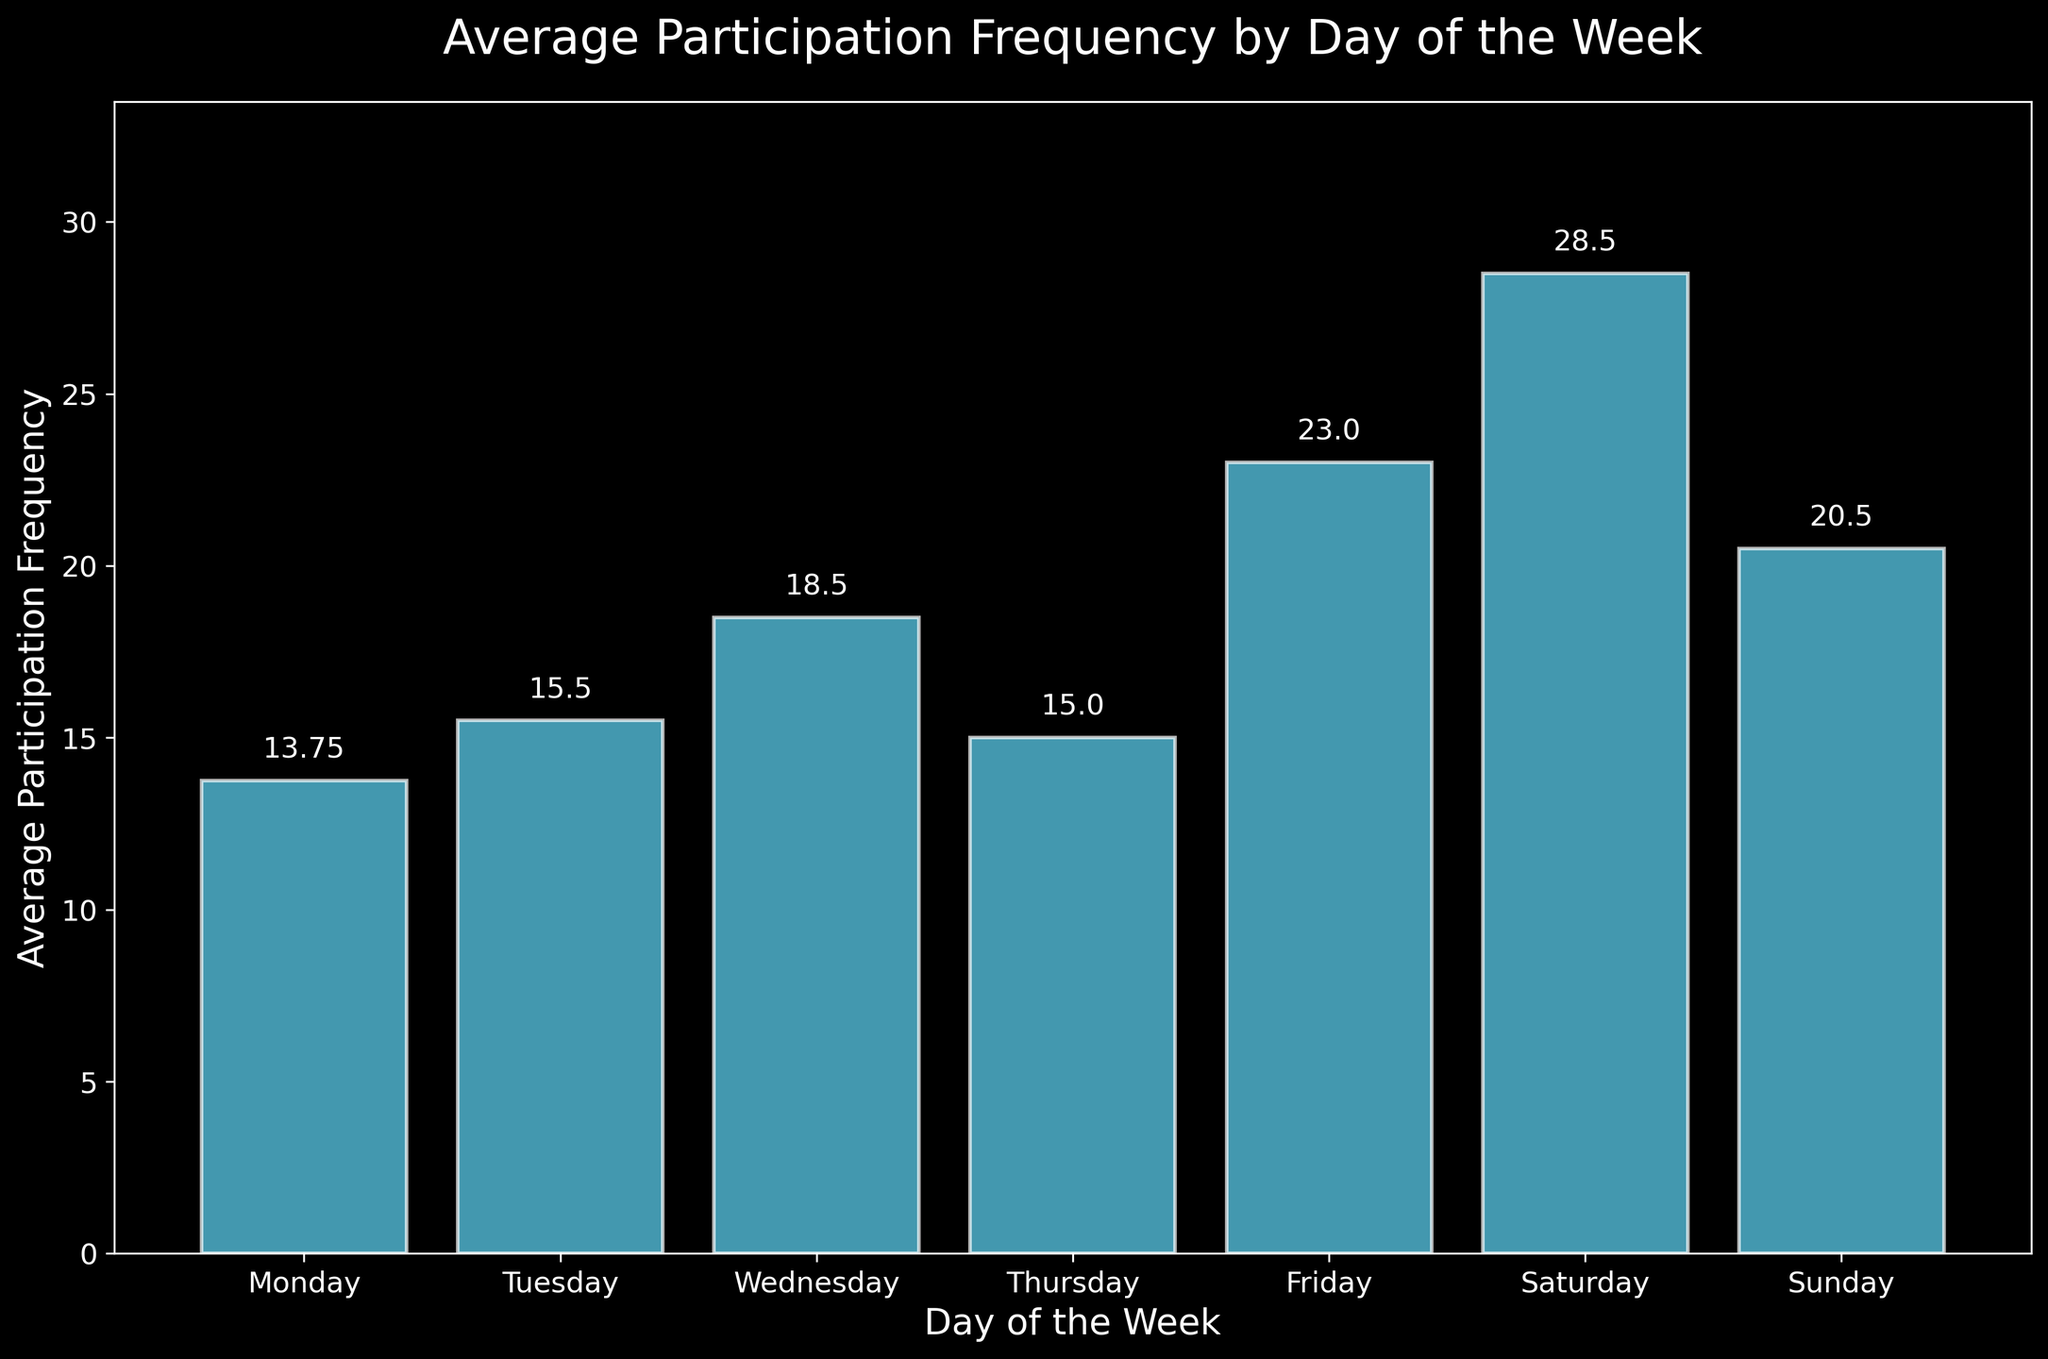Which day has the highest average participation frequency? From the figure, the bar representing Saturday is the tallest, indicating that it has the highest average participation frequency.
Answer: Saturday What is the difference in average participation between the highest and lowest days? The highest average participation is on Saturday (28.8) and the lowest is on Monday (13.75). The difference is calculated as 28.8 - 13.75 = 15.05.
Answer: 15.05 How does the average participation frequency on Friday compare to Sunday? From the figure, Friday has an average participation frequency of 23.0, while Sunday has 20.5. So, Friday's is higher than Sunday's.
Answer: Friday’s is higher What is the total average participation frequency for the weekends (Saturday and Sunday)? Saturday has an average of 28.8 and Sunday has 20.5. Summing these gives 28.8 + 20.5 = 49.3.
Answer: 49.3 Which day of the week has an average participation frequency closest to the median of all the days? The average frequencies are 13.75 (Monday), 15.5 (Tuesday), 18.5 (Wednesday), 15.0 (Thursday), 23.0 (Friday), 28.8 (Saturday), and 20.5 (Sunday). The median is the fourth value in the ordered list: 18.5. Friday's average (23.0) is closest to the median (18.5).
Answer: Wednesday Between which two consecutive days is there the largest increase in average participation frequency? Comparing consecutive days: Monday to Tuesday (1.75), Tuesday to Wednesday (3.0), Wednesday to Thursday (-3.5), Thursday to Friday (8.0), Friday to Saturday (5.8), Saturday to Sunday (-8.3). The largest increase is from Thursday to Friday (8.0).
Answer: Thursday to Friday What is the average participation frequency for the first half of the week (Monday to Thursday)? The averages for Monday (13.75), Tuesday (15.5), Wednesday (18.5), and Thursday (15.0). The total is 13.75 + 15.5 + 18.5 + 15.0 = 62.75 and the average is 62.75 / 4 = 15.6875.
Answer: 15.69 Which weekday (Monday to Friday) has the lowest average participation frequency? From the figure, the bars representing Monday (13.75) is the shortest among weekdays.
Answer: Monday What is the percentage increase in average participation frequency from Monday to Friday? Monday's average is 13.75 and Friday's is 23.0. The percentage increase is calculated as ((23.0 - 13.75) / 13.75) * 100 = 67.27%.
Answer: 67.27% Which day has an average participation frequency closest to 20? From the figure, Wednesday has an average participation frequency of 18.5, which is closest to 20.
Answer: Wednesday 